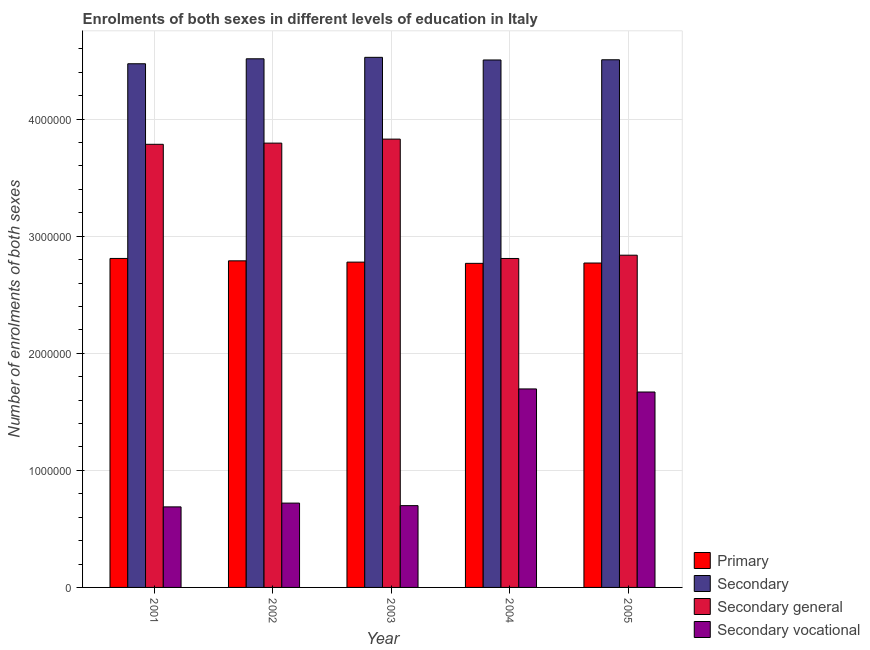How many different coloured bars are there?
Provide a short and direct response. 4. Are the number of bars on each tick of the X-axis equal?
Provide a succinct answer. Yes. How many bars are there on the 3rd tick from the right?
Provide a short and direct response. 4. What is the label of the 1st group of bars from the left?
Provide a short and direct response. 2001. In how many cases, is the number of bars for a given year not equal to the number of legend labels?
Your answer should be compact. 0. What is the number of enrolments in primary education in 2002?
Provide a short and direct response. 2.79e+06. Across all years, what is the maximum number of enrolments in secondary general education?
Offer a terse response. 3.83e+06. Across all years, what is the minimum number of enrolments in secondary general education?
Provide a short and direct response. 2.81e+06. In which year was the number of enrolments in secondary general education maximum?
Keep it short and to the point. 2003. In which year was the number of enrolments in secondary education minimum?
Provide a succinct answer. 2001. What is the total number of enrolments in secondary education in the graph?
Give a very brief answer. 2.25e+07. What is the difference between the number of enrolments in primary education in 2002 and that in 2003?
Your answer should be very brief. 1.10e+04. What is the difference between the number of enrolments in primary education in 2004 and the number of enrolments in secondary education in 2003?
Your response must be concise. -1.05e+04. What is the average number of enrolments in secondary general education per year?
Provide a short and direct response. 3.41e+06. In the year 2005, what is the difference between the number of enrolments in secondary general education and number of enrolments in secondary vocational education?
Make the answer very short. 0. What is the ratio of the number of enrolments in secondary general education in 2002 to that in 2005?
Offer a very short reply. 1.34. Is the difference between the number of enrolments in secondary general education in 2001 and 2004 greater than the difference between the number of enrolments in secondary education in 2001 and 2004?
Offer a terse response. No. What is the difference between the highest and the second highest number of enrolments in primary education?
Provide a succinct answer. 2.05e+04. What is the difference between the highest and the lowest number of enrolments in secondary vocational education?
Your response must be concise. 1.01e+06. What does the 2nd bar from the left in 2002 represents?
Provide a short and direct response. Secondary. What does the 3rd bar from the right in 2004 represents?
Your response must be concise. Secondary. Is it the case that in every year, the sum of the number of enrolments in primary education and number of enrolments in secondary education is greater than the number of enrolments in secondary general education?
Your answer should be very brief. Yes. Are all the bars in the graph horizontal?
Your answer should be very brief. No. Are the values on the major ticks of Y-axis written in scientific E-notation?
Provide a short and direct response. No. Does the graph contain any zero values?
Offer a terse response. No. Where does the legend appear in the graph?
Provide a short and direct response. Bottom right. How many legend labels are there?
Your response must be concise. 4. How are the legend labels stacked?
Provide a succinct answer. Vertical. What is the title of the graph?
Give a very brief answer. Enrolments of both sexes in different levels of education in Italy. Does "First 20% of population" appear as one of the legend labels in the graph?
Your answer should be very brief. No. What is the label or title of the X-axis?
Make the answer very short. Year. What is the label or title of the Y-axis?
Make the answer very short. Number of enrolments of both sexes. What is the Number of enrolments of both sexes of Primary in 2001?
Keep it short and to the point. 2.81e+06. What is the Number of enrolments of both sexes of Secondary in 2001?
Your answer should be very brief. 4.47e+06. What is the Number of enrolments of both sexes in Secondary general in 2001?
Offer a very short reply. 3.79e+06. What is the Number of enrolments of both sexes of Secondary vocational in 2001?
Offer a very short reply. 6.88e+05. What is the Number of enrolments of both sexes of Primary in 2002?
Give a very brief answer. 2.79e+06. What is the Number of enrolments of both sexes of Secondary in 2002?
Give a very brief answer. 4.52e+06. What is the Number of enrolments of both sexes of Secondary general in 2002?
Give a very brief answer. 3.80e+06. What is the Number of enrolments of both sexes in Secondary vocational in 2002?
Provide a short and direct response. 7.20e+05. What is the Number of enrolments of both sexes of Primary in 2003?
Offer a very short reply. 2.78e+06. What is the Number of enrolments of both sexes of Secondary in 2003?
Keep it short and to the point. 4.53e+06. What is the Number of enrolments of both sexes of Secondary general in 2003?
Provide a short and direct response. 3.83e+06. What is the Number of enrolments of both sexes of Secondary vocational in 2003?
Make the answer very short. 6.99e+05. What is the Number of enrolments of both sexes in Primary in 2004?
Make the answer very short. 2.77e+06. What is the Number of enrolments of both sexes in Secondary in 2004?
Offer a very short reply. 4.51e+06. What is the Number of enrolments of both sexes in Secondary general in 2004?
Your response must be concise. 2.81e+06. What is the Number of enrolments of both sexes of Secondary vocational in 2004?
Your answer should be very brief. 1.70e+06. What is the Number of enrolments of both sexes of Primary in 2005?
Ensure brevity in your answer.  2.77e+06. What is the Number of enrolments of both sexes of Secondary in 2005?
Your answer should be very brief. 4.51e+06. What is the Number of enrolments of both sexes in Secondary general in 2005?
Ensure brevity in your answer.  2.84e+06. What is the Number of enrolments of both sexes of Secondary vocational in 2005?
Offer a terse response. 1.67e+06. Across all years, what is the maximum Number of enrolments of both sexes of Primary?
Offer a terse response. 2.81e+06. Across all years, what is the maximum Number of enrolments of both sexes in Secondary?
Your response must be concise. 4.53e+06. Across all years, what is the maximum Number of enrolments of both sexes in Secondary general?
Offer a very short reply. 3.83e+06. Across all years, what is the maximum Number of enrolments of both sexes in Secondary vocational?
Your response must be concise. 1.70e+06. Across all years, what is the minimum Number of enrolments of both sexes in Primary?
Provide a short and direct response. 2.77e+06. Across all years, what is the minimum Number of enrolments of both sexes in Secondary?
Provide a succinct answer. 4.47e+06. Across all years, what is the minimum Number of enrolments of both sexes in Secondary general?
Provide a succinct answer. 2.81e+06. Across all years, what is the minimum Number of enrolments of both sexes of Secondary vocational?
Your answer should be very brief. 6.88e+05. What is the total Number of enrolments of both sexes of Primary in the graph?
Your answer should be very brief. 1.39e+07. What is the total Number of enrolments of both sexes in Secondary in the graph?
Ensure brevity in your answer.  2.25e+07. What is the total Number of enrolments of both sexes in Secondary general in the graph?
Offer a very short reply. 1.71e+07. What is the total Number of enrolments of both sexes in Secondary vocational in the graph?
Your answer should be compact. 5.47e+06. What is the difference between the Number of enrolments of both sexes of Primary in 2001 and that in 2002?
Provide a succinct answer. 2.05e+04. What is the difference between the Number of enrolments of both sexes in Secondary in 2001 and that in 2002?
Your answer should be compact. -4.24e+04. What is the difference between the Number of enrolments of both sexes in Secondary general in 2001 and that in 2002?
Offer a very short reply. -1.02e+04. What is the difference between the Number of enrolments of both sexes of Secondary vocational in 2001 and that in 2002?
Keep it short and to the point. -3.23e+04. What is the difference between the Number of enrolments of both sexes in Primary in 2001 and that in 2003?
Provide a succinct answer. 3.15e+04. What is the difference between the Number of enrolments of both sexes in Secondary in 2001 and that in 2003?
Make the answer very short. -5.49e+04. What is the difference between the Number of enrolments of both sexes in Secondary general in 2001 and that in 2003?
Offer a very short reply. -4.43e+04. What is the difference between the Number of enrolments of both sexes of Secondary vocational in 2001 and that in 2003?
Ensure brevity in your answer.  -1.06e+04. What is the difference between the Number of enrolments of both sexes of Primary in 2001 and that in 2004?
Your answer should be very brief. 4.20e+04. What is the difference between the Number of enrolments of both sexes of Secondary in 2001 and that in 2004?
Offer a very short reply. -3.23e+04. What is the difference between the Number of enrolments of both sexes of Secondary general in 2001 and that in 2004?
Keep it short and to the point. 9.75e+05. What is the difference between the Number of enrolments of both sexes of Secondary vocational in 2001 and that in 2004?
Give a very brief answer. -1.01e+06. What is the difference between the Number of enrolments of both sexes of Primary in 2001 and that in 2005?
Offer a terse response. 3.91e+04. What is the difference between the Number of enrolments of both sexes of Secondary in 2001 and that in 2005?
Make the answer very short. -3.40e+04. What is the difference between the Number of enrolments of both sexes in Secondary general in 2001 and that in 2005?
Ensure brevity in your answer.  9.47e+05. What is the difference between the Number of enrolments of both sexes in Secondary vocational in 2001 and that in 2005?
Your answer should be compact. -9.81e+05. What is the difference between the Number of enrolments of both sexes of Primary in 2002 and that in 2003?
Your response must be concise. 1.10e+04. What is the difference between the Number of enrolments of both sexes in Secondary in 2002 and that in 2003?
Your response must be concise. -1.25e+04. What is the difference between the Number of enrolments of both sexes in Secondary general in 2002 and that in 2003?
Your response must be concise. -3.41e+04. What is the difference between the Number of enrolments of both sexes in Secondary vocational in 2002 and that in 2003?
Your answer should be very brief. 2.16e+04. What is the difference between the Number of enrolments of both sexes in Primary in 2002 and that in 2004?
Provide a succinct answer. 2.15e+04. What is the difference between the Number of enrolments of both sexes in Secondary in 2002 and that in 2004?
Provide a short and direct response. 1.01e+04. What is the difference between the Number of enrolments of both sexes of Secondary general in 2002 and that in 2004?
Give a very brief answer. 9.85e+05. What is the difference between the Number of enrolments of both sexes of Secondary vocational in 2002 and that in 2004?
Offer a very short reply. -9.75e+05. What is the difference between the Number of enrolments of both sexes in Primary in 2002 and that in 2005?
Your answer should be compact. 1.86e+04. What is the difference between the Number of enrolments of both sexes of Secondary in 2002 and that in 2005?
Your response must be concise. 8394. What is the difference between the Number of enrolments of both sexes of Secondary general in 2002 and that in 2005?
Make the answer very short. 9.57e+05. What is the difference between the Number of enrolments of both sexes in Secondary vocational in 2002 and that in 2005?
Offer a terse response. -9.49e+05. What is the difference between the Number of enrolments of both sexes in Primary in 2003 and that in 2004?
Make the answer very short. 1.05e+04. What is the difference between the Number of enrolments of both sexes in Secondary in 2003 and that in 2004?
Offer a terse response. 2.26e+04. What is the difference between the Number of enrolments of both sexes of Secondary general in 2003 and that in 2004?
Offer a very short reply. 1.02e+06. What is the difference between the Number of enrolments of both sexes of Secondary vocational in 2003 and that in 2004?
Offer a terse response. -9.97e+05. What is the difference between the Number of enrolments of both sexes of Primary in 2003 and that in 2005?
Provide a short and direct response. 7630. What is the difference between the Number of enrolments of both sexes of Secondary in 2003 and that in 2005?
Provide a short and direct response. 2.09e+04. What is the difference between the Number of enrolments of both sexes in Secondary general in 2003 and that in 2005?
Give a very brief answer. 9.92e+05. What is the difference between the Number of enrolments of both sexes of Secondary vocational in 2003 and that in 2005?
Give a very brief answer. -9.71e+05. What is the difference between the Number of enrolments of both sexes in Primary in 2004 and that in 2005?
Offer a terse response. -2861. What is the difference between the Number of enrolments of both sexes in Secondary in 2004 and that in 2005?
Ensure brevity in your answer.  -1709. What is the difference between the Number of enrolments of both sexes in Secondary general in 2004 and that in 2005?
Keep it short and to the point. -2.79e+04. What is the difference between the Number of enrolments of both sexes of Secondary vocational in 2004 and that in 2005?
Make the answer very short. 2.62e+04. What is the difference between the Number of enrolments of both sexes in Primary in 2001 and the Number of enrolments of both sexes in Secondary in 2002?
Your response must be concise. -1.71e+06. What is the difference between the Number of enrolments of both sexes in Primary in 2001 and the Number of enrolments of both sexes in Secondary general in 2002?
Offer a terse response. -9.85e+05. What is the difference between the Number of enrolments of both sexes of Primary in 2001 and the Number of enrolments of both sexes of Secondary vocational in 2002?
Ensure brevity in your answer.  2.09e+06. What is the difference between the Number of enrolments of both sexes in Secondary in 2001 and the Number of enrolments of both sexes in Secondary general in 2002?
Your answer should be very brief. 6.78e+05. What is the difference between the Number of enrolments of both sexes in Secondary in 2001 and the Number of enrolments of both sexes in Secondary vocational in 2002?
Ensure brevity in your answer.  3.75e+06. What is the difference between the Number of enrolments of both sexes of Secondary general in 2001 and the Number of enrolments of both sexes of Secondary vocational in 2002?
Give a very brief answer. 3.06e+06. What is the difference between the Number of enrolments of both sexes in Primary in 2001 and the Number of enrolments of both sexes in Secondary in 2003?
Keep it short and to the point. -1.72e+06. What is the difference between the Number of enrolments of both sexes in Primary in 2001 and the Number of enrolments of both sexes in Secondary general in 2003?
Make the answer very short. -1.02e+06. What is the difference between the Number of enrolments of both sexes in Primary in 2001 and the Number of enrolments of both sexes in Secondary vocational in 2003?
Offer a terse response. 2.11e+06. What is the difference between the Number of enrolments of both sexes of Secondary in 2001 and the Number of enrolments of both sexes of Secondary general in 2003?
Your answer should be very brief. 6.44e+05. What is the difference between the Number of enrolments of both sexes of Secondary in 2001 and the Number of enrolments of both sexes of Secondary vocational in 2003?
Provide a short and direct response. 3.77e+06. What is the difference between the Number of enrolments of both sexes of Secondary general in 2001 and the Number of enrolments of both sexes of Secondary vocational in 2003?
Offer a terse response. 3.09e+06. What is the difference between the Number of enrolments of both sexes of Primary in 2001 and the Number of enrolments of both sexes of Secondary in 2004?
Your answer should be compact. -1.70e+06. What is the difference between the Number of enrolments of both sexes of Primary in 2001 and the Number of enrolments of both sexes of Secondary general in 2004?
Offer a terse response. 287. What is the difference between the Number of enrolments of both sexes in Primary in 2001 and the Number of enrolments of both sexes in Secondary vocational in 2004?
Your answer should be very brief. 1.11e+06. What is the difference between the Number of enrolments of both sexes of Secondary in 2001 and the Number of enrolments of both sexes of Secondary general in 2004?
Your response must be concise. 1.66e+06. What is the difference between the Number of enrolments of both sexes of Secondary in 2001 and the Number of enrolments of both sexes of Secondary vocational in 2004?
Your answer should be compact. 2.78e+06. What is the difference between the Number of enrolments of both sexes of Secondary general in 2001 and the Number of enrolments of both sexes of Secondary vocational in 2004?
Provide a short and direct response. 2.09e+06. What is the difference between the Number of enrolments of both sexes in Primary in 2001 and the Number of enrolments of both sexes in Secondary in 2005?
Your answer should be very brief. -1.70e+06. What is the difference between the Number of enrolments of both sexes in Primary in 2001 and the Number of enrolments of both sexes in Secondary general in 2005?
Offer a very short reply. -2.77e+04. What is the difference between the Number of enrolments of both sexes of Primary in 2001 and the Number of enrolments of both sexes of Secondary vocational in 2005?
Provide a short and direct response. 1.14e+06. What is the difference between the Number of enrolments of both sexes in Secondary in 2001 and the Number of enrolments of both sexes in Secondary general in 2005?
Provide a succinct answer. 1.64e+06. What is the difference between the Number of enrolments of both sexes of Secondary in 2001 and the Number of enrolments of both sexes of Secondary vocational in 2005?
Your answer should be very brief. 2.80e+06. What is the difference between the Number of enrolments of both sexes in Secondary general in 2001 and the Number of enrolments of both sexes in Secondary vocational in 2005?
Provide a short and direct response. 2.12e+06. What is the difference between the Number of enrolments of both sexes of Primary in 2002 and the Number of enrolments of both sexes of Secondary in 2003?
Make the answer very short. -1.74e+06. What is the difference between the Number of enrolments of both sexes of Primary in 2002 and the Number of enrolments of both sexes of Secondary general in 2003?
Your response must be concise. -1.04e+06. What is the difference between the Number of enrolments of both sexes of Primary in 2002 and the Number of enrolments of both sexes of Secondary vocational in 2003?
Your answer should be very brief. 2.09e+06. What is the difference between the Number of enrolments of both sexes of Secondary in 2002 and the Number of enrolments of both sexes of Secondary general in 2003?
Your response must be concise. 6.86e+05. What is the difference between the Number of enrolments of both sexes in Secondary in 2002 and the Number of enrolments of both sexes in Secondary vocational in 2003?
Your answer should be compact. 3.82e+06. What is the difference between the Number of enrolments of both sexes in Secondary general in 2002 and the Number of enrolments of both sexes in Secondary vocational in 2003?
Your answer should be compact. 3.10e+06. What is the difference between the Number of enrolments of both sexes of Primary in 2002 and the Number of enrolments of both sexes of Secondary in 2004?
Provide a short and direct response. -1.72e+06. What is the difference between the Number of enrolments of both sexes in Primary in 2002 and the Number of enrolments of both sexes in Secondary general in 2004?
Your response must be concise. -2.02e+04. What is the difference between the Number of enrolments of both sexes in Primary in 2002 and the Number of enrolments of both sexes in Secondary vocational in 2004?
Offer a terse response. 1.09e+06. What is the difference between the Number of enrolments of both sexes of Secondary in 2002 and the Number of enrolments of both sexes of Secondary general in 2004?
Provide a short and direct response. 1.71e+06. What is the difference between the Number of enrolments of both sexes in Secondary in 2002 and the Number of enrolments of both sexes in Secondary vocational in 2004?
Ensure brevity in your answer.  2.82e+06. What is the difference between the Number of enrolments of both sexes in Secondary general in 2002 and the Number of enrolments of both sexes in Secondary vocational in 2004?
Ensure brevity in your answer.  2.10e+06. What is the difference between the Number of enrolments of both sexes in Primary in 2002 and the Number of enrolments of both sexes in Secondary in 2005?
Your response must be concise. -1.72e+06. What is the difference between the Number of enrolments of both sexes of Primary in 2002 and the Number of enrolments of both sexes of Secondary general in 2005?
Provide a succinct answer. -4.81e+04. What is the difference between the Number of enrolments of both sexes in Primary in 2002 and the Number of enrolments of both sexes in Secondary vocational in 2005?
Your response must be concise. 1.12e+06. What is the difference between the Number of enrolments of both sexes of Secondary in 2002 and the Number of enrolments of both sexes of Secondary general in 2005?
Give a very brief answer. 1.68e+06. What is the difference between the Number of enrolments of both sexes of Secondary in 2002 and the Number of enrolments of both sexes of Secondary vocational in 2005?
Your response must be concise. 2.85e+06. What is the difference between the Number of enrolments of both sexes of Secondary general in 2002 and the Number of enrolments of both sexes of Secondary vocational in 2005?
Make the answer very short. 2.13e+06. What is the difference between the Number of enrolments of both sexes in Primary in 2003 and the Number of enrolments of both sexes in Secondary in 2004?
Keep it short and to the point. -1.73e+06. What is the difference between the Number of enrolments of both sexes in Primary in 2003 and the Number of enrolments of both sexes in Secondary general in 2004?
Ensure brevity in your answer.  -3.12e+04. What is the difference between the Number of enrolments of both sexes of Primary in 2003 and the Number of enrolments of both sexes of Secondary vocational in 2004?
Your answer should be compact. 1.08e+06. What is the difference between the Number of enrolments of both sexes of Secondary in 2003 and the Number of enrolments of both sexes of Secondary general in 2004?
Offer a terse response. 1.72e+06. What is the difference between the Number of enrolments of both sexes in Secondary in 2003 and the Number of enrolments of both sexes in Secondary vocational in 2004?
Provide a succinct answer. 2.83e+06. What is the difference between the Number of enrolments of both sexes of Secondary general in 2003 and the Number of enrolments of both sexes of Secondary vocational in 2004?
Make the answer very short. 2.13e+06. What is the difference between the Number of enrolments of both sexes of Primary in 2003 and the Number of enrolments of both sexes of Secondary in 2005?
Provide a short and direct response. -1.73e+06. What is the difference between the Number of enrolments of both sexes in Primary in 2003 and the Number of enrolments of both sexes in Secondary general in 2005?
Provide a succinct answer. -5.91e+04. What is the difference between the Number of enrolments of both sexes of Primary in 2003 and the Number of enrolments of both sexes of Secondary vocational in 2005?
Make the answer very short. 1.11e+06. What is the difference between the Number of enrolments of both sexes of Secondary in 2003 and the Number of enrolments of both sexes of Secondary general in 2005?
Make the answer very short. 1.69e+06. What is the difference between the Number of enrolments of both sexes in Secondary in 2003 and the Number of enrolments of both sexes in Secondary vocational in 2005?
Offer a very short reply. 2.86e+06. What is the difference between the Number of enrolments of both sexes of Secondary general in 2003 and the Number of enrolments of both sexes of Secondary vocational in 2005?
Your answer should be compact. 2.16e+06. What is the difference between the Number of enrolments of both sexes in Primary in 2004 and the Number of enrolments of both sexes in Secondary in 2005?
Your answer should be compact. -1.74e+06. What is the difference between the Number of enrolments of both sexes in Primary in 2004 and the Number of enrolments of both sexes in Secondary general in 2005?
Ensure brevity in your answer.  -6.96e+04. What is the difference between the Number of enrolments of both sexes in Primary in 2004 and the Number of enrolments of both sexes in Secondary vocational in 2005?
Provide a succinct answer. 1.10e+06. What is the difference between the Number of enrolments of both sexes in Secondary in 2004 and the Number of enrolments of both sexes in Secondary general in 2005?
Make the answer very short. 1.67e+06. What is the difference between the Number of enrolments of both sexes of Secondary in 2004 and the Number of enrolments of both sexes of Secondary vocational in 2005?
Your answer should be very brief. 2.84e+06. What is the difference between the Number of enrolments of both sexes in Secondary general in 2004 and the Number of enrolments of both sexes in Secondary vocational in 2005?
Your answer should be very brief. 1.14e+06. What is the average Number of enrolments of both sexes of Primary per year?
Offer a terse response. 2.78e+06. What is the average Number of enrolments of both sexes of Secondary per year?
Provide a succinct answer. 4.51e+06. What is the average Number of enrolments of both sexes of Secondary general per year?
Make the answer very short. 3.41e+06. What is the average Number of enrolments of both sexes of Secondary vocational per year?
Offer a very short reply. 1.09e+06. In the year 2001, what is the difference between the Number of enrolments of both sexes in Primary and Number of enrolments of both sexes in Secondary?
Provide a succinct answer. -1.66e+06. In the year 2001, what is the difference between the Number of enrolments of both sexes of Primary and Number of enrolments of both sexes of Secondary general?
Your answer should be very brief. -9.75e+05. In the year 2001, what is the difference between the Number of enrolments of both sexes in Primary and Number of enrolments of both sexes in Secondary vocational?
Offer a terse response. 2.12e+06. In the year 2001, what is the difference between the Number of enrolments of both sexes of Secondary and Number of enrolments of both sexes of Secondary general?
Offer a very short reply. 6.88e+05. In the year 2001, what is the difference between the Number of enrolments of both sexes in Secondary and Number of enrolments of both sexes in Secondary vocational?
Offer a terse response. 3.79e+06. In the year 2001, what is the difference between the Number of enrolments of both sexes of Secondary general and Number of enrolments of both sexes of Secondary vocational?
Your response must be concise. 3.10e+06. In the year 2002, what is the difference between the Number of enrolments of both sexes of Primary and Number of enrolments of both sexes of Secondary?
Keep it short and to the point. -1.73e+06. In the year 2002, what is the difference between the Number of enrolments of both sexes of Primary and Number of enrolments of both sexes of Secondary general?
Offer a very short reply. -1.01e+06. In the year 2002, what is the difference between the Number of enrolments of both sexes in Primary and Number of enrolments of both sexes in Secondary vocational?
Offer a terse response. 2.07e+06. In the year 2002, what is the difference between the Number of enrolments of both sexes in Secondary and Number of enrolments of both sexes in Secondary general?
Provide a succinct answer. 7.20e+05. In the year 2002, what is the difference between the Number of enrolments of both sexes of Secondary and Number of enrolments of both sexes of Secondary vocational?
Your response must be concise. 3.80e+06. In the year 2002, what is the difference between the Number of enrolments of both sexes of Secondary general and Number of enrolments of both sexes of Secondary vocational?
Provide a succinct answer. 3.08e+06. In the year 2003, what is the difference between the Number of enrolments of both sexes of Primary and Number of enrolments of both sexes of Secondary?
Offer a terse response. -1.75e+06. In the year 2003, what is the difference between the Number of enrolments of both sexes in Primary and Number of enrolments of both sexes in Secondary general?
Your response must be concise. -1.05e+06. In the year 2003, what is the difference between the Number of enrolments of both sexes of Primary and Number of enrolments of both sexes of Secondary vocational?
Offer a terse response. 2.08e+06. In the year 2003, what is the difference between the Number of enrolments of both sexes of Secondary and Number of enrolments of both sexes of Secondary general?
Provide a succinct answer. 6.99e+05. In the year 2003, what is the difference between the Number of enrolments of both sexes of Secondary and Number of enrolments of both sexes of Secondary vocational?
Offer a terse response. 3.83e+06. In the year 2003, what is the difference between the Number of enrolments of both sexes of Secondary general and Number of enrolments of both sexes of Secondary vocational?
Provide a short and direct response. 3.13e+06. In the year 2004, what is the difference between the Number of enrolments of both sexes of Primary and Number of enrolments of both sexes of Secondary?
Your response must be concise. -1.74e+06. In the year 2004, what is the difference between the Number of enrolments of both sexes in Primary and Number of enrolments of both sexes in Secondary general?
Make the answer very short. -4.17e+04. In the year 2004, what is the difference between the Number of enrolments of both sexes in Primary and Number of enrolments of both sexes in Secondary vocational?
Keep it short and to the point. 1.07e+06. In the year 2004, what is the difference between the Number of enrolments of both sexes in Secondary and Number of enrolments of both sexes in Secondary general?
Give a very brief answer. 1.70e+06. In the year 2004, what is the difference between the Number of enrolments of both sexes in Secondary and Number of enrolments of both sexes in Secondary vocational?
Keep it short and to the point. 2.81e+06. In the year 2004, what is the difference between the Number of enrolments of both sexes of Secondary general and Number of enrolments of both sexes of Secondary vocational?
Provide a succinct answer. 1.11e+06. In the year 2005, what is the difference between the Number of enrolments of both sexes in Primary and Number of enrolments of both sexes in Secondary?
Your answer should be very brief. -1.74e+06. In the year 2005, what is the difference between the Number of enrolments of both sexes of Primary and Number of enrolments of both sexes of Secondary general?
Give a very brief answer. -6.68e+04. In the year 2005, what is the difference between the Number of enrolments of both sexes of Primary and Number of enrolments of both sexes of Secondary vocational?
Your answer should be compact. 1.10e+06. In the year 2005, what is the difference between the Number of enrolments of both sexes of Secondary and Number of enrolments of both sexes of Secondary general?
Offer a very short reply. 1.67e+06. In the year 2005, what is the difference between the Number of enrolments of both sexes of Secondary and Number of enrolments of both sexes of Secondary vocational?
Offer a very short reply. 2.84e+06. In the year 2005, what is the difference between the Number of enrolments of both sexes in Secondary general and Number of enrolments of both sexes in Secondary vocational?
Make the answer very short. 1.17e+06. What is the ratio of the Number of enrolments of both sexes of Primary in 2001 to that in 2002?
Give a very brief answer. 1.01. What is the ratio of the Number of enrolments of both sexes of Secondary in 2001 to that in 2002?
Your response must be concise. 0.99. What is the ratio of the Number of enrolments of both sexes in Secondary general in 2001 to that in 2002?
Make the answer very short. 1. What is the ratio of the Number of enrolments of both sexes of Secondary vocational in 2001 to that in 2002?
Ensure brevity in your answer.  0.96. What is the ratio of the Number of enrolments of both sexes in Primary in 2001 to that in 2003?
Your response must be concise. 1.01. What is the ratio of the Number of enrolments of both sexes in Secondary in 2001 to that in 2003?
Provide a succinct answer. 0.99. What is the ratio of the Number of enrolments of both sexes of Secondary general in 2001 to that in 2003?
Your answer should be compact. 0.99. What is the ratio of the Number of enrolments of both sexes of Primary in 2001 to that in 2004?
Your answer should be compact. 1.02. What is the ratio of the Number of enrolments of both sexes in Secondary in 2001 to that in 2004?
Offer a very short reply. 0.99. What is the ratio of the Number of enrolments of both sexes in Secondary general in 2001 to that in 2004?
Provide a succinct answer. 1.35. What is the ratio of the Number of enrolments of both sexes of Secondary vocational in 2001 to that in 2004?
Your answer should be compact. 0.41. What is the ratio of the Number of enrolments of both sexes in Primary in 2001 to that in 2005?
Offer a very short reply. 1.01. What is the ratio of the Number of enrolments of both sexes in Secondary in 2001 to that in 2005?
Your response must be concise. 0.99. What is the ratio of the Number of enrolments of both sexes in Secondary general in 2001 to that in 2005?
Give a very brief answer. 1.33. What is the ratio of the Number of enrolments of both sexes in Secondary vocational in 2001 to that in 2005?
Give a very brief answer. 0.41. What is the ratio of the Number of enrolments of both sexes in Secondary in 2002 to that in 2003?
Keep it short and to the point. 1. What is the ratio of the Number of enrolments of both sexes in Secondary general in 2002 to that in 2003?
Keep it short and to the point. 0.99. What is the ratio of the Number of enrolments of both sexes in Secondary vocational in 2002 to that in 2003?
Your answer should be very brief. 1.03. What is the ratio of the Number of enrolments of both sexes in Primary in 2002 to that in 2004?
Give a very brief answer. 1.01. What is the ratio of the Number of enrolments of both sexes of Secondary general in 2002 to that in 2004?
Ensure brevity in your answer.  1.35. What is the ratio of the Number of enrolments of both sexes in Secondary vocational in 2002 to that in 2004?
Keep it short and to the point. 0.42. What is the ratio of the Number of enrolments of both sexes of Primary in 2002 to that in 2005?
Provide a short and direct response. 1.01. What is the ratio of the Number of enrolments of both sexes of Secondary general in 2002 to that in 2005?
Provide a short and direct response. 1.34. What is the ratio of the Number of enrolments of both sexes of Secondary vocational in 2002 to that in 2005?
Your response must be concise. 0.43. What is the ratio of the Number of enrolments of both sexes of Secondary in 2003 to that in 2004?
Your response must be concise. 1. What is the ratio of the Number of enrolments of both sexes in Secondary general in 2003 to that in 2004?
Your answer should be very brief. 1.36. What is the ratio of the Number of enrolments of both sexes of Secondary vocational in 2003 to that in 2004?
Your response must be concise. 0.41. What is the ratio of the Number of enrolments of both sexes in Secondary in 2003 to that in 2005?
Your answer should be compact. 1. What is the ratio of the Number of enrolments of both sexes in Secondary general in 2003 to that in 2005?
Keep it short and to the point. 1.35. What is the ratio of the Number of enrolments of both sexes of Secondary vocational in 2003 to that in 2005?
Your answer should be very brief. 0.42. What is the ratio of the Number of enrolments of both sexes in Secondary in 2004 to that in 2005?
Your answer should be compact. 1. What is the ratio of the Number of enrolments of both sexes in Secondary general in 2004 to that in 2005?
Your answer should be compact. 0.99. What is the ratio of the Number of enrolments of both sexes of Secondary vocational in 2004 to that in 2005?
Provide a short and direct response. 1.02. What is the difference between the highest and the second highest Number of enrolments of both sexes in Primary?
Give a very brief answer. 2.05e+04. What is the difference between the highest and the second highest Number of enrolments of both sexes in Secondary?
Give a very brief answer. 1.25e+04. What is the difference between the highest and the second highest Number of enrolments of both sexes of Secondary general?
Make the answer very short. 3.41e+04. What is the difference between the highest and the second highest Number of enrolments of both sexes of Secondary vocational?
Offer a very short reply. 2.62e+04. What is the difference between the highest and the lowest Number of enrolments of both sexes in Primary?
Your answer should be very brief. 4.20e+04. What is the difference between the highest and the lowest Number of enrolments of both sexes of Secondary?
Keep it short and to the point. 5.49e+04. What is the difference between the highest and the lowest Number of enrolments of both sexes of Secondary general?
Your response must be concise. 1.02e+06. What is the difference between the highest and the lowest Number of enrolments of both sexes in Secondary vocational?
Provide a short and direct response. 1.01e+06. 